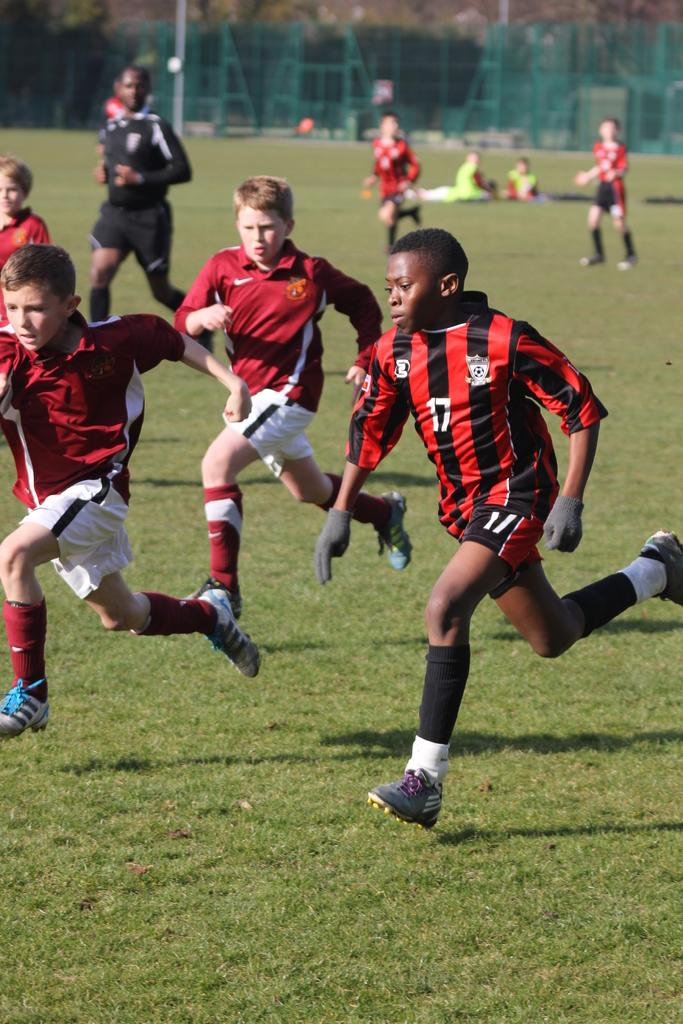<image>
Share a concise interpretation of the image provided. Youth soccer player in orange and black with 17 on the shirt. 